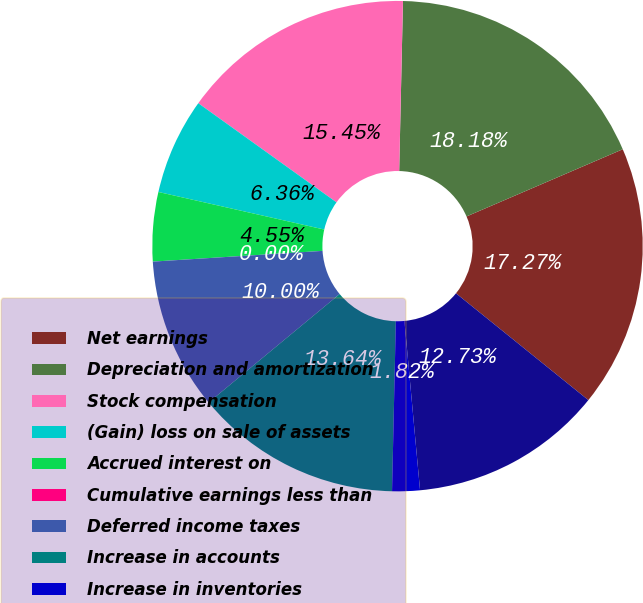Convert chart to OTSL. <chart><loc_0><loc_0><loc_500><loc_500><pie_chart><fcel>Net earnings<fcel>Depreciation and amortization<fcel>Stock compensation<fcel>(Gain) loss on sale of assets<fcel>Accrued interest on<fcel>Cumulative earnings less than<fcel>Deferred income taxes<fcel>Increase in accounts<fcel>Increase in inventories<fcel>(Increase) decrease in prepaid<nl><fcel>17.27%<fcel>18.18%<fcel>15.45%<fcel>6.36%<fcel>4.55%<fcel>0.0%<fcel>10.0%<fcel>13.64%<fcel>1.82%<fcel>12.73%<nl></chart> 